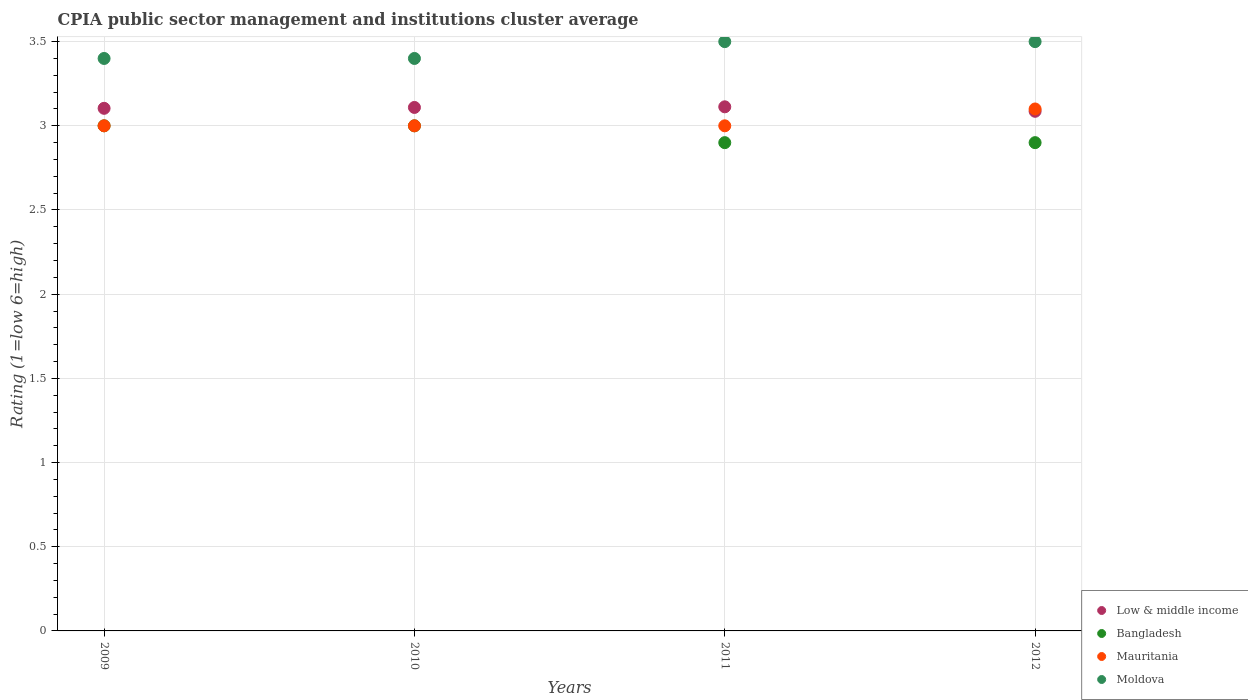How many different coloured dotlines are there?
Give a very brief answer. 4. What is the CPIA rating in Low & middle income in 2011?
Provide a succinct answer. 3.11. Across all years, what is the maximum CPIA rating in Low & middle income?
Your answer should be very brief. 3.11. Across all years, what is the minimum CPIA rating in Moldova?
Offer a very short reply. 3.4. In which year was the CPIA rating in Moldova maximum?
Your answer should be very brief. 2011. What is the total CPIA rating in Moldova in the graph?
Make the answer very short. 13.8. What is the difference between the CPIA rating in Mauritania in 2009 and the CPIA rating in Low & middle income in 2012?
Your response must be concise. -0.09. What is the average CPIA rating in Low & middle income per year?
Provide a succinct answer. 3.1. In the year 2010, what is the difference between the CPIA rating in Moldova and CPIA rating in Bangladesh?
Ensure brevity in your answer.  0.4. In how many years, is the CPIA rating in Moldova greater than 2.5?
Your response must be concise. 4. What is the ratio of the CPIA rating in Mauritania in 2011 to that in 2012?
Ensure brevity in your answer.  0.97. Is the difference between the CPIA rating in Moldova in 2010 and 2012 greater than the difference between the CPIA rating in Bangladesh in 2010 and 2012?
Your answer should be very brief. No. What is the difference between the highest and the lowest CPIA rating in Low & middle income?
Your answer should be very brief. 0.03. In how many years, is the CPIA rating in Bangladesh greater than the average CPIA rating in Bangladesh taken over all years?
Your response must be concise. 2. Is the sum of the CPIA rating in Moldova in 2009 and 2012 greater than the maximum CPIA rating in Low & middle income across all years?
Make the answer very short. Yes. Is it the case that in every year, the sum of the CPIA rating in Moldova and CPIA rating in Mauritania  is greater than the sum of CPIA rating in Low & middle income and CPIA rating in Bangladesh?
Your response must be concise. Yes. Is the CPIA rating in Low & middle income strictly less than the CPIA rating in Moldova over the years?
Give a very brief answer. Yes. How many dotlines are there?
Offer a terse response. 4. How many years are there in the graph?
Your response must be concise. 4. Does the graph contain grids?
Give a very brief answer. Yes. What is the title of the graph?
Provide a short and direct response. CPIA public sector management and institutions cluster average. Does "Turkmenistan" appear as one of the legend labels in the graph?
Offer a very short reply. No. What is the label or title of the X-axis?
Provide a succinct answer. Years. What is the Rating (1=low 6=high) in Low & middle income in 2009?
Give a very brief answer. 3.1. What is the Rating (1=low 6=high) in Low & middle income in 2010?
Provide a succinct answer. 3.11. What is the Rating (1=low 6=high) of Mauritania in 2010?
Make the answer very short. 3. What is the Rating (1=low 6=high) in Low & middle income in 2011?
Provide a short and direct response. 3.11. What is the Rating (1=low 6=high) in Low & middle income in 2012?
Your answer should be very brief. 3.09. What is the Rating (1=low 6=high) in Moldova in 2012?
Your answer should be very brief. 3.5. Across all years, what is the maximum Rating (1=low 6=high) in Low & middle income?
Offer a terse response. 3.11. Across all years, what is the minimum Rating (1=low 6=high) of Low & middle income?
Offer a very short reply. 3.09. Across all years, what is the minimum Rating (1=low 6=high) in Bangladesh?
Your answer should be compact. 2.9. What is the total Rating (1=low 6=high) of Low & middle income in the graph?
Offer a very short reply. 12.41. What is the total Rating (1=low 6=high) of Mauritania in the graph?
Provide a short and direct response. 12.1. What is the difference between the Rating (1=low 6=high) in Low & middle income in 2009 and that in 2010?
Offer a terse response. -0.01. What is the difference between the Rating (1=low 6=high) in Moldova in 2009 and that in 2010?
Your response must be concise. 0. What is the difference between the Rating (1=low 6=high) in Low & middle income in 2009 and that in 2011?
Make the answer very short. -0.01. What is the difference between the Rating (1=low 6=high) of Bangladesh in 2009 and that in 2011?
Offer a very short reply. 0.1. What is the difference between the Rating (1=low 6=high) of Low & middle income in 2009 and that in 2012?
Your answer should be compact. 0.02. What is the difference between the Rating (1=low 6=high) of Mauritania in 2009 and that in 2012?
Give a very brief answer. -0.1. What is the difference between the Rating (1=low 6=high) of Moldova in 2009 and that in 2012?
Ensure brevity in your answer.  -0.1. What is the difference between the Rating (1=low 6=high) in Low & middle income in 2010 and that in 2011?
Your answer should be compact. -0. What is the difference between the Rating (1=low 6=high) in Mauritania in 2010 and that in 2011?
Your answer should be very brief. 0. What is the difference between the Rating (1=low 6=high) in Low & middle income in 2010 and that in 2012?
Give a very brief answer. 0.02. What is the difference between the Rating (1=low 6=high) of Mauritania in 2010 and that in 2012?
Ensure brevity in your answer.  -0.1. What is the difference between the Rating (1=low 6=high) in Moldova in 2010 and that in 2012?
Give a very brief answer. -0.1. What is the difference between the Rating (1=low 6=high) in Low & middle income in 2011 and that in 2012?
Give a very brief answer. 0.03. What is the difference between the Rating (1=low 6=high) in Bangladesh in 2011 and that in 2012?
Provide a succinct answer. 0. What is the difference between the Rating (1=low 6=high) of Low & middle income in 2009 and the Rating (1=low 6=high) of Bangladesh in 2010?
Make the answer very short. 0.1. What is the difference between the Rating (1=low 6=high) of Low & middle income in 2009 and the Rating (1=low 6=high) of Mauritania in 2010?
Ensure brevity in your answer.  0.1. What is the difference between the Rating (1=low 6=high) of Low & middle income in 2009 and the Rating (1=low 6=high) of Moldova in 2010?
Your response must be concise. -0.3. What is the difference between the Rating (1=low 6=high) of Bangladesh in 2009 and the Rating (1=low 6=high) of Moldova in 2010?
Give a very brief answer. -0.4. What is the difference between the Rating (1=low 6=high) in Mauritania in 2009 and the Rating (1=low 6=high) in Moldova in 2010?
Make the answer very short. -0.4. What is the difference between the Rating (1=low 6=high) of Low & middle income in 2009 and the Rating (1=low 6=high) of Bangladesh in 2011?
Provide a short and direct response. 0.2. What is the difference between the Rating (1=low 6=high) in Low & middle income in 2009 and the Rating (1=low 6=high) in Mauritania in 2011?
Keep it short and to the point. 0.1. What is the difference between the Rating (1=low 6=high) in Low & middle income in 2009 and the Rating (1=low 6=high) in Moldova in 2011?
Offer a terse response. -0.4. What is the difference between the Rating (1=low 6=high) in Bangladesh in 2009 and the Rating (1=low 6=high) in Mauritania in 2011?
Ensure brevity in your answer.  0. What is the difference between the Rating (1=low 6=high) in Bangladesh in 2009 and the Rating (1=low 6=high) in Moldova in 2011?
Keep it short and to the point. -0.5. What is the difference between the Rating (1=low 6=high) of Low & middle income in 2009 and the Rating (1=low 6=high) of Bangladesh in 2012?
Provide a succinct answer. 0.2. What is the difference between the Rating (1=low 6=high) in Low & middle income in 2009 and the Rating (1=low 6=high) in Mauritania in 2012?
Make the answer very short. 0. What is the difference between the Rating (1=low 6=high) of Low & middle income in 2009 and the Rating (1=low 6=high) of Moldova in 2012?
Your answer should be compact. -0.4. What is the difference between the Rating (1=low 6=high) of Bangladesh in 2009 and the Rating (1=low 6=high) of Mauritania in 2012?
Your response must be concise. -0.1. What is the difference between the Rating (1=low 6=high) of Bangladesh in 2009 and the Rating (1=low 6=high) of Moldova in 2012?
Offer a terse response. -0.5. What is the difference between the Rating (1=low 6=high) of Low & middle income in 2010 and the Rating (1=low 6=high) of Bangladesh in 2011?
Provide a short and direct response. 0.21. What is the difference between the Rating (1=low 6=high) in Low & middle income in 2010 and the Rating (1=low 6=high) in Mauritania in 2011?
Offer a terse response. 0.11. What is the difference between the Rating (1=low 6=high) in Low & middle income in 2010 and the Rating (1=low 6=high) in Moldova in 2011?
Your response must be concise. -0.39. What is the difference between the Rating (1=low 6=high) of Bangladesh in 2010 and the Rating (1=low 6=high) of Moldova in 2011?
Keep it short and to the point. -0.5. What is the difference between the Rating (1=low 6=high) of Mauritania in 2010 and the Rating (1=low 6=high) of Moldova in 2011?
Your response must be concise. -0.5. What is the difference between the Rating (1=low 6=high) in Low & middle income in 2010 and the Rating (1=low 6=high) in Bangladesh in 2012?
Ensure brevity in your answer.  0.21. What is the difference between the Rating (1=low 6=high) of Low & middle income in 2010 and the Rating (1=low 6=high) of Mauritania in 2012?
Give a very brief answer. 0.01. What is the difference between the Rating (1=low 6=high) in Low & middle income in 2010 and the Rating (1=low 6=high) in Moldova in 2012?
Make the answer very short. -0.39. What is the difference between the Rating (1=low 6=high) of Mauritania in 2010 and the Rating (1=low 6=high) of Moldova in 2012?
Your answer should be compact. -0.5. What is the difference between the Rating (1=low 6=high) of Low & middle income in 2011 and the Rating (1=low 6=high) of Bangladesh in 2012?
Ensure brevity in your answer.  0.21. What is the difference between the Rating (1=low 6=high) of Low & middle income in 2011 and the Rating (1=low 6=high) of Mauritania in 2012?
Provide a short and direct response. 0.01. What is the difference between the Rating (1=low 6=high) of Low & middle income in 2011 and the Rating (1=low 6=high) of Moldova in 2012?
Keep it short and to the point. -0.39. What is the difference between the Rating (1=low 6=high) in Bangladesh in 2011 and the Rating (1=low 6=high) in Moldova in 2012?
Offer a very short reply. -0.6. What is the average Rating (1=low 6=high) in Low & middle income per year?
Offer a very short reply. 3.1. What is the average Rating (1=low 6=high) in Bangladesh per year?
Ensure brevity in your answer.  2.95. What is the average Rating (1=low 6=high) of Mauritania per year?
Make the answer very short. 3.02. What is the average Rating (1=low 6=high) in Moldova per year?
Give a very brief answer. 3.45. In the year 2009, what is the difference between the Rating (1=low 6=high) of Low & middle income and Rating (1=low 6=high) of Bangladesh?
Your answer should be compact. 0.1. In the year 2009, what is the difference between the Rating (1=low 6=high) in Low & middle income and Rating (1=low 6=high) in Mauritania?
Your answer should be compact. 0.1. In the year 2009, what is the difference between the Rating (1=low 6=high) in Low & middle income and Rating (1=low 6=high) in Moldova?
Provide a succinct answer. -0.3. In the year 2009, what is the difference between the Rating (1=low 6=high) in Bangladesh and Rating (1=low 6=high) in Mauritania?
Provide a short and direct response. 0. In the year 2009, what is the difference between the Rating (1=low 6=high) in Mauritania and Rating (1=low 6=high) in Moldova?
Provide a short and direct response. -0.4. In the year 2010, what is the difference between the Rating (1=low 6=high) in Low & middle income and Rating (1=low 6=high) in Bangladesh?
Make the answer very short. 0.11. In the year 2010, what is the difference between the Rating (1=low 6=high) in Low & middle income and Rating (1=low 6=high) in Mauritania?
Your answer should be compact. 0.11. In the year 2010, what is the difference between the Rating (1=low 6=high) in Low & middle income and Rating (1=low 6=high) in Moldova?
Your answer should be very brief. -0.29. In the year 2010, what is the difference between the Rating (1=low 6=high) in Bangladesh and Rating (1=low 6=high) in Mauritania?
Make the answer very short. 0. In the year 2010, what is the difference between the Rating (1=low 6=high) of Bangladesh and Rating (1=low 6=high) of Moldova?
Your answer should be compact. -0.4. In the year 2010, what is the difference between the Rating (1=low 6=high) of Mauritania and Rating (1=low 6=high) of Moldova?
Ensure brevity in your answer.  -0.4. In the year 2011, what is the difference between the Rating (1=low 6=high) in Low & middle income and Rating (1=low 6=high) in Bangladesh?
Keep it short and to the point. 0.21. In the year 2011, what is the difference between the Rating (1=low 6=high) of Low & middle income and Rating (1=low 6=high) of Mauritania?
Keep it short and to the point. 0.11. In the year 2011, what is the difference between the Rating (1=low 6=high) of Low & middle income and Rating (1=low 6=high) of Moldova?
Keep it short and to the point. -0.39. In the year 2011, what is the difference between the Rating (1=low 6=high) of Bangladesh and Rating (1=low 6=high) of Mauritania?
Provide a succinct answer. -0.1. In the year 2011, what is the difference between the Rating (1=low 6=high) of Bangladesh and Rating (1=low 6=high) of Moldova?
Ensure brevity in your answer.  -0.6. In the year 2011, what is the difference between the Rating (1=low 6=high) of Mauritania and Rating (1=low 6=high) of Moldova?
Give a very brief answer. -0.5. In the year 2012, what is the difference between the Rating (1=low 6=high) in Low & middle income and Rating (1=low 6=high) in Bangladesh?
Your answer should be very brief. 0.19. In the year 2012, what is the difference between the Rating (1=low 6=high) in Low & middle income and Rating (1=low 6=high) in Mauritania?
Your response must be concise. -0.01. In the year 2012, what is the difference between the Rating (1=low 6=high) in Low & middle income and Rating (1=low 6=high) in Moldova?
Your answer should be very brief. -0.41. In the year 2012, what is the difference between the Rating (1=low 6=high) in Bangladesh and Rating (1=low 6=high) in Moldova?
Provide a short and direct response. -0.6. What is the ratio of the Rating (1=low 6=high) in Low & middle income in 2009 to that in 2011?
Give a very brief answer. 1. What is the ratio of the Rating (1=low 6=high) of Bangladesh in 2009 to that in 2011?
Provide a succinct answer. 1.03. What is the ratio of the Rating (1=low 6=high) of Mauritania in 2009 to that in 2011?
Give a very brief answer. 1. What is the ratio of the Rating (1=low 6=high) in Moldova in 2009 to that in 2011?
Your answer should be compact. 0.97. What is the ratio of the Rating (1=low 6=high) in Low & middle income in 2009 to that in 2012?
Your answer should be very brief. 1.01. What is the ratio of the Rating (1=low 6=high) of Bangladesh in 2009 to that in 2012?
Offer a very short reply. 1.03. What is the ratio of the Rating (1=low 6=high) in Moldova in 2009 to that in 2012?
Your response must be concise. 0.97. What is the ratio of the Rating (1=low 6=high) of Bangladesh in 2010 to that in 2011?
Your answer should be very brief. 1.03. What is the ratio of the Rating (1=low 6=high) of Moldova in 2010 to that in 2011?
Your answer should be very brief. 0.97. What is the ratio of the Rating (1=low 6=high) in Low & middle income in 2010 to that in 2012?
Your answer should be compact. 1.01. What is the ratio of the Rating (1=low 6=high) of Bangladesh in 2010 to that in 2012?
Offer a terse response. 1.03. What is the ratio of the Rating (1=low 6=high) of Moldova in 2010 to that in 2012?
Make the answer very short. 0.97. What is the ratio of the Rating (1=low 6=high) of Low & middle income in 2011 to that in 2012?
Your answer should be compact. 1.01. What is the difference between the highest and the second highest Rating (1=low 6=high) in Low & middle income?
Your response must be concise. 0. What is the difference between the highest and the second highest Rating (1=low 6=high) of Mauritania?
Ensure brevity in your answer.  0.1. What is the difference between the highest and the lowest Rating (1=low 6=high) of Low & middle income?
Your answer should be very brief. 0.03. What is the difference between the highest and the lowest Rating (1=low 6=high) in Bangladesh?
Offer a very short reply. 0.1. What is the difference between the highest and the lowest Rating (1=low 6=high) in Moldova?
Keep it short and to the point. 0.1. 